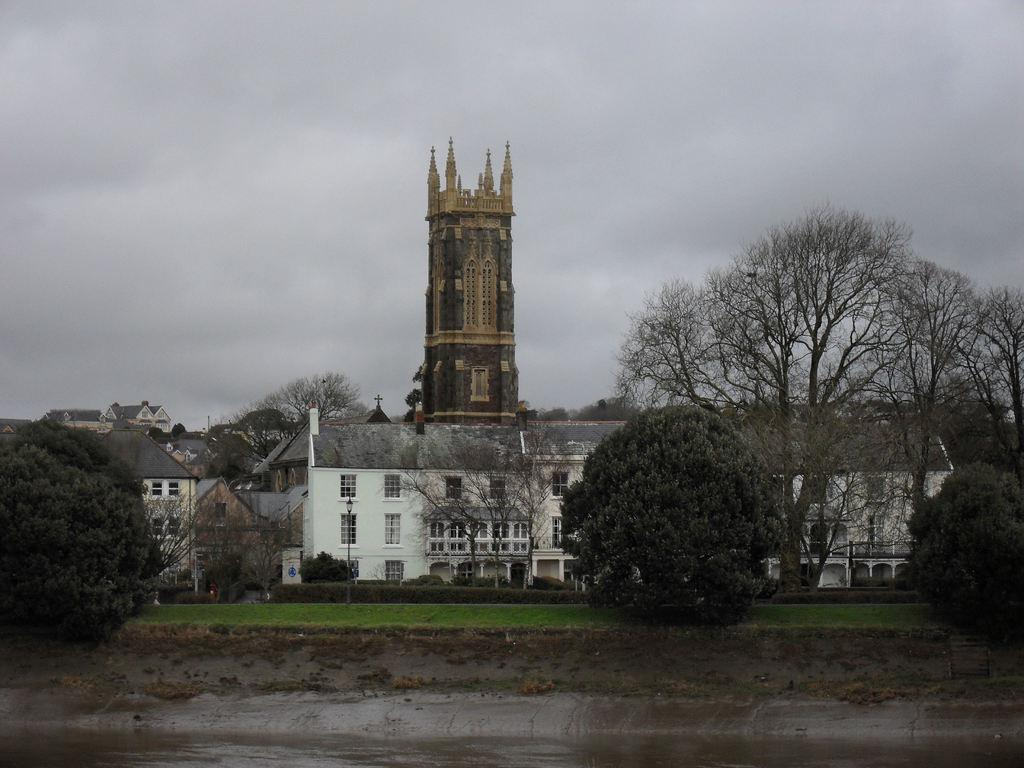What is at the bottom of the image? There is water at the bottom of the image. What type of water is depicted in the image? The water appears to be a sea. What can be seen in the background of the image? There are buildings and trees in the background of the image. What is visible at the top of the image? The sky is visible at the top of the image. What type of neck accessory is being worn by the cat in the image? There is no cat present in the image, so it is not possible to answer that question. 